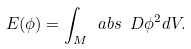Convert formula to latex. <formula><loc_0><loc_0><loc_500><loc_500>E ( \phi ) = \int _ { M } \ a b s { \ D \phi } ^ { 2 } d V .</formula> 